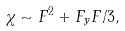Convert formula to latex. <formula><loc_0><loc_0><loc_500><loc_500>\chi \sim F ^ { 2 } + F _ { y } F / 3 ,</formula> 